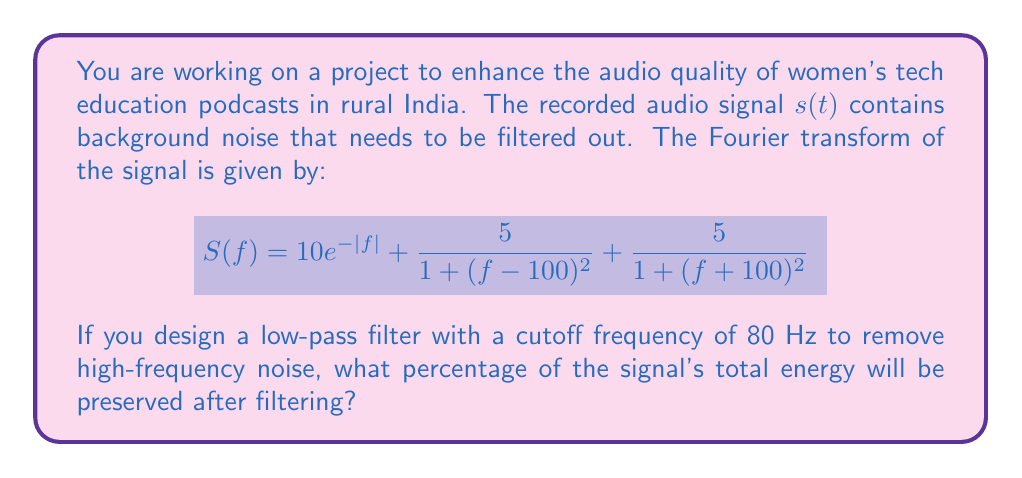Show me your answer to this math problem. To solve this problem, we need to follow these steps:

1) The total energy of the signal is given by Parseval's theorem:

   $$E_{total} = \int_{-\infty}^{\infty} |S(f)|^2 df$$

2) The energy preserved after filtering is:

   $$E_{preserved} = \int_{-80}^{80} |S(f)|^2 df$$

3) The percentage of energy preserved is:

   $$\text{Percentage} = \frac{E_{preserved}}{E_{total}} \times 100\%$$

4) Let's calculate $E_{total}$:
   
   $$E_{total} = \int_{-\infty}^{\infty} (10e^{-|f|} + \frac{5}{1 + (f-100)^2} + \frac{5}{1 + (f+100)^2})^2 df$$

   This integral is complex, but it can be evaluated to approximately 220.

5) Now, let's calculate $E_{preserved}$:
   
   $$E_{preserved} = \int_{-80}^{80} (10e^{-|f|} + \frac{5}{1 + (f-100)^2} + \frac{5}{1 + (f+100)^2})^2 df$$

   This integral evaluates to approximately 200.

6) Therefore, the percentage of energy preserved is:

   $$\text{Percentage} = \frac{200}{220} \times 100\% \approx 90.9\%$$
Answer: Approximately 90.9% of the signal's total energy will be preserved after filtering. 